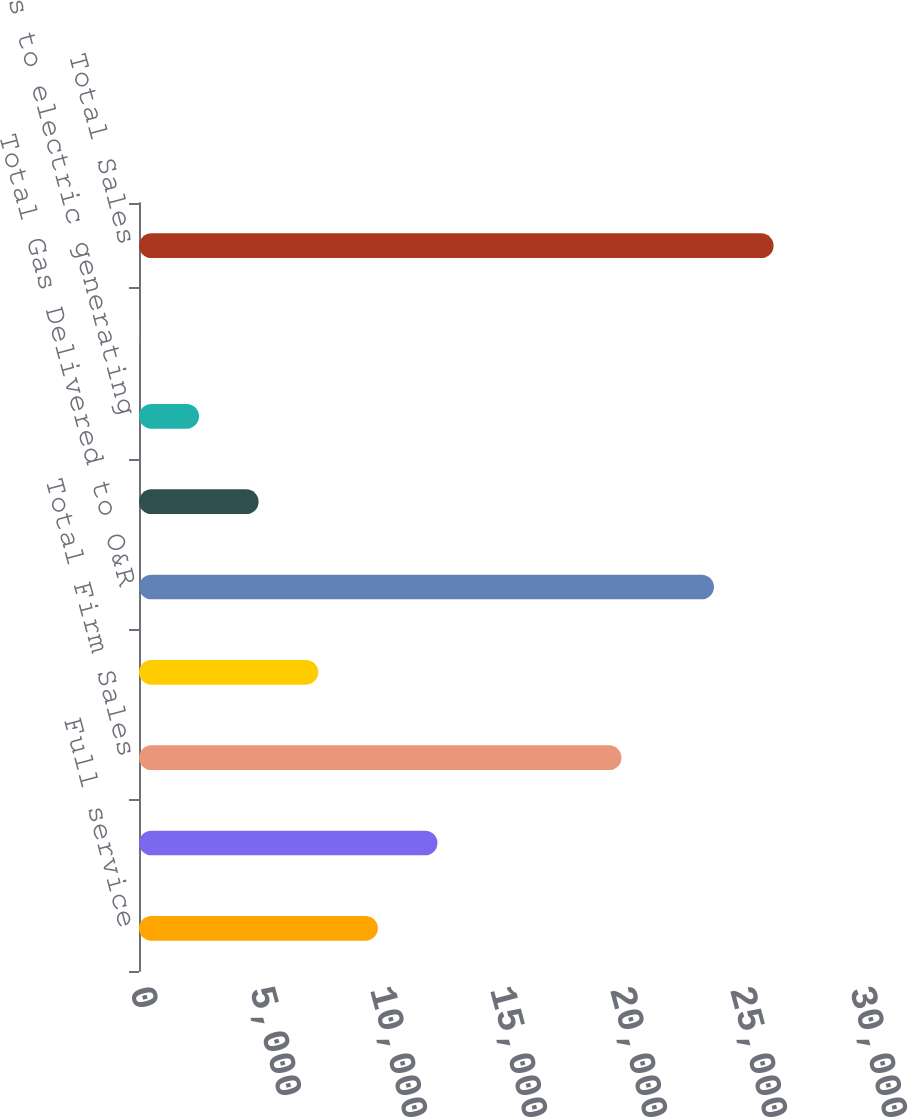Convert chart. <chart><loc_0><loc_0><loc_500><loc_500><bar_chart><fcel>Full service<fcel>Firm transportation<fcel>Total Firm Sales<fcel>Interruptible sales<fcel>Total Gas Delivered to O&R<fcel>Sales for resale<fcel>Sales to electric generating<fcel>Off-system sales<fcel>Total Sales<nl><fcel>9952.8<fcel>12437<fcel>20104<fcel>7468.6<fcel>23957<fcel>4984.4<fcel>2500.2<fcel>16<fcel>26441.2<nl></chart> 